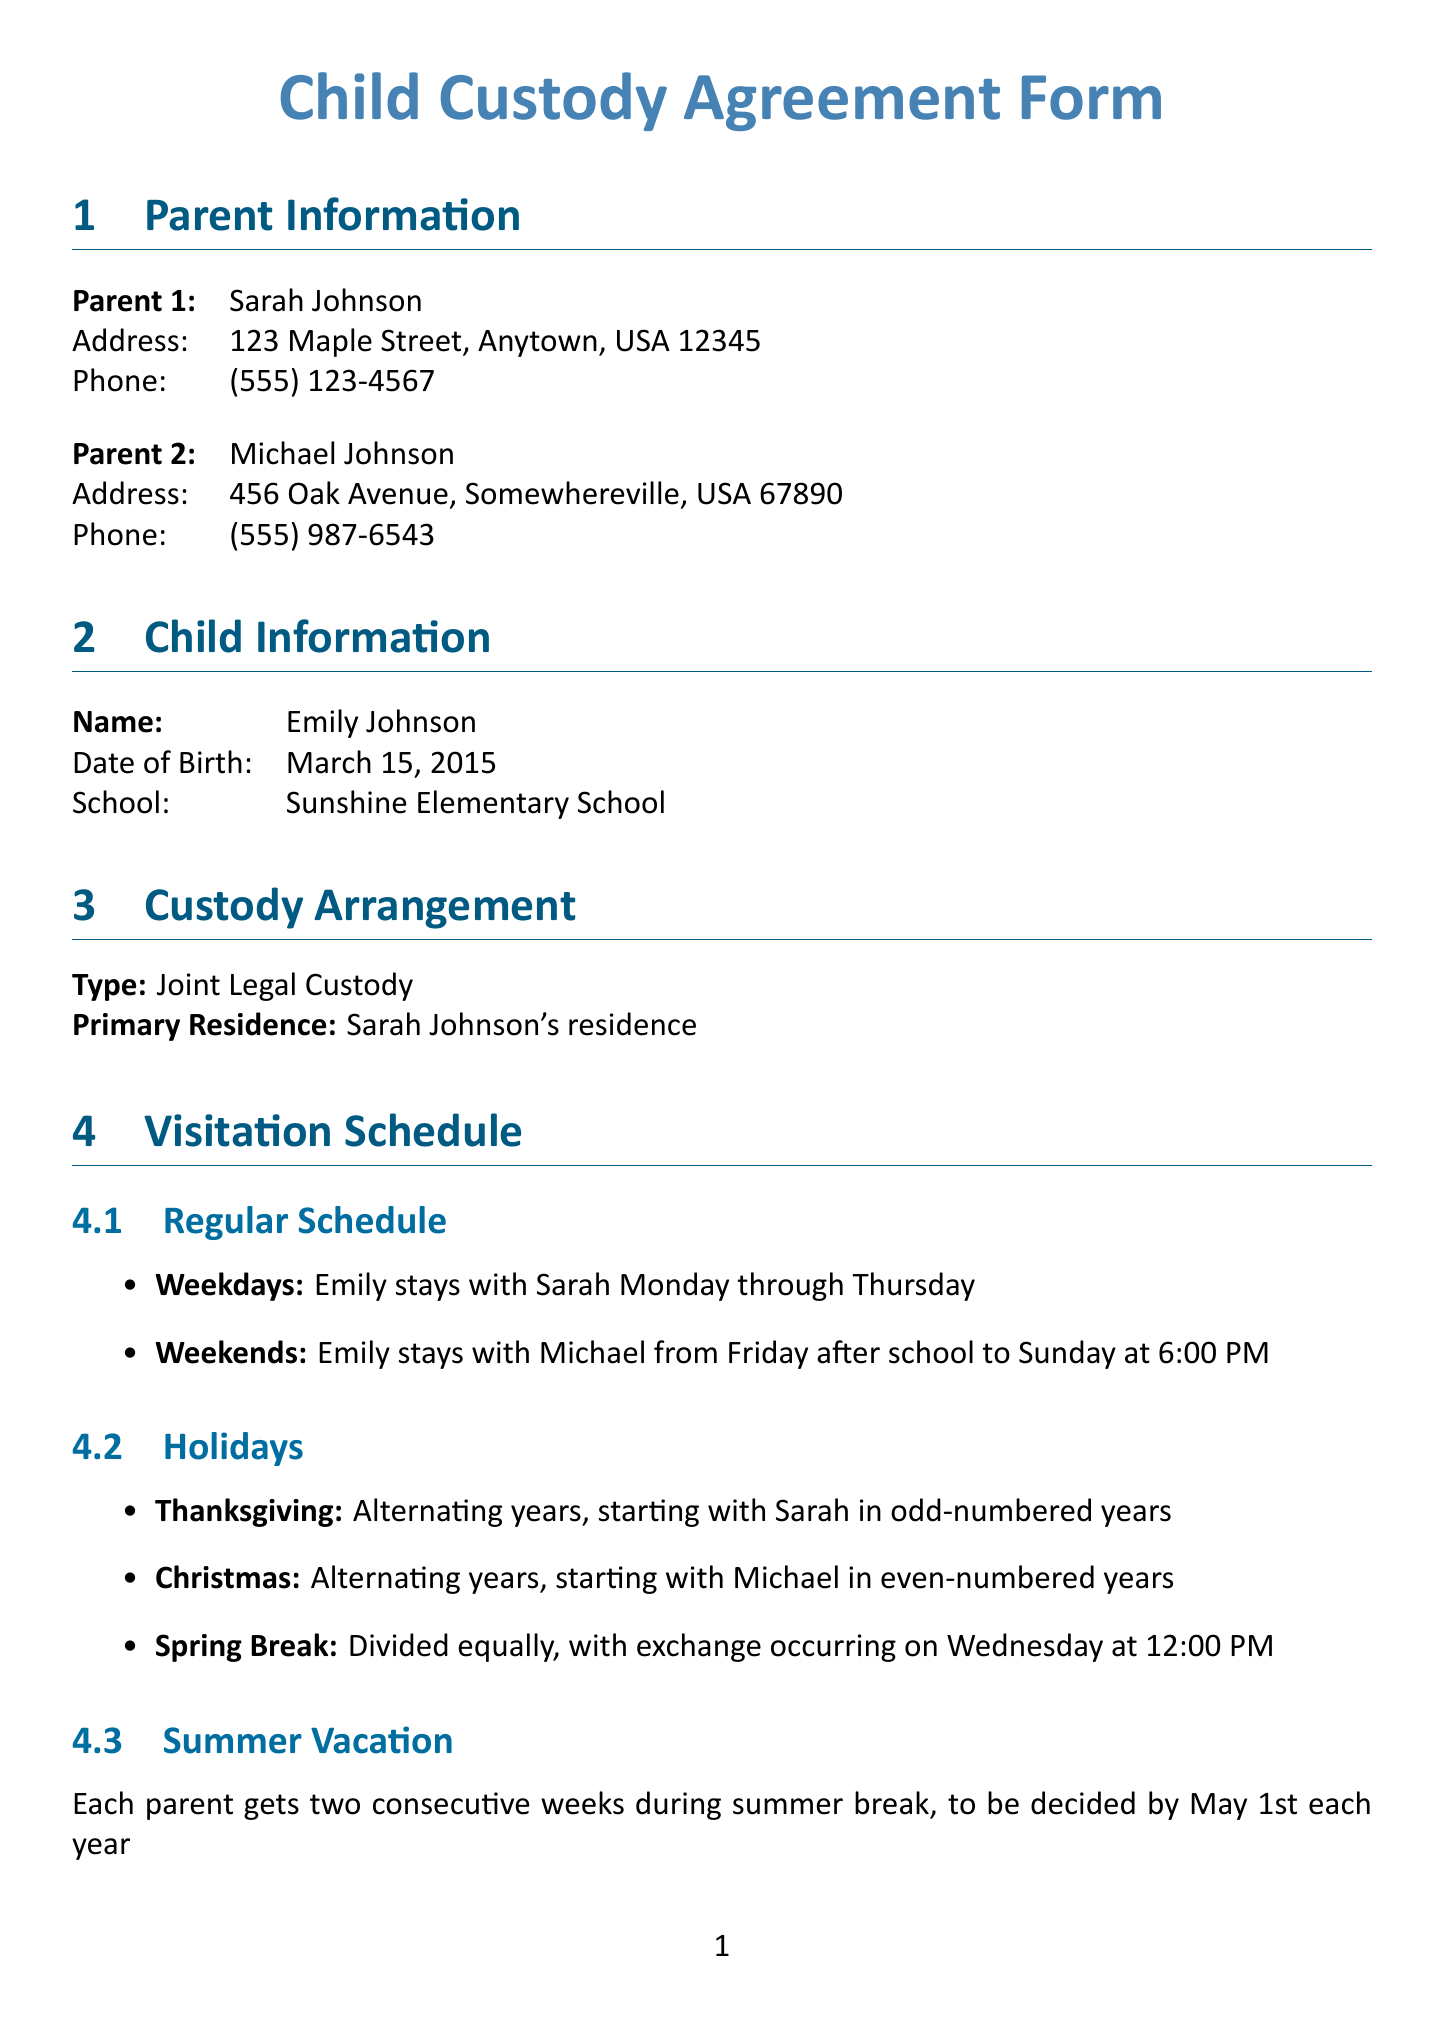What is the primary residence of Emily? The primary residence of Emily is listed as being with Sarah Johnson in the custody arrangement section.
Answer: Sarah Johnson's residence Who is responsible for purchasing school supplies? In the financial responsibilities section, it specifies that Sarah is responsible for purchasing school supplies.
Answer: Sarah How much is the child support payment? The document states the child support amount to be paid by Michael Johnson each month.
Answer: $800 per month What app is used for non-emergency communications? The communication guidelines section specifies the use of a co-parenting app for communication between parents.
Answer: OurFamilyWizard How are uninsured medical expenses handled? The financial responsibilities section details the handling of uninsured medical expenses, indicating the shared responsibility.
Answer: Split 50/50 between both parents What is the method for dispute resolution? The document outlines the method for resolving disputes between parents in the dispute resolution section.
Answer: Mediation through Family Mediation Services What is the holiday visitation schedule for Thanksgiving? The visitation schedule section specifies the arrangement for Thanksgiving visitation.
Answer: Alternating years, starting with Sarah in odd-numbered years How many weeks of summer vacation does each parent get? The summer vacation section states the arrangement for summer breaks shared between parents.
Answer: Two consecutive weeks What date is the child support payment due? The financial responsibilities section clearly indicates the due date for the child support payment from Michael Johnson.
Answer: 1st of each month 